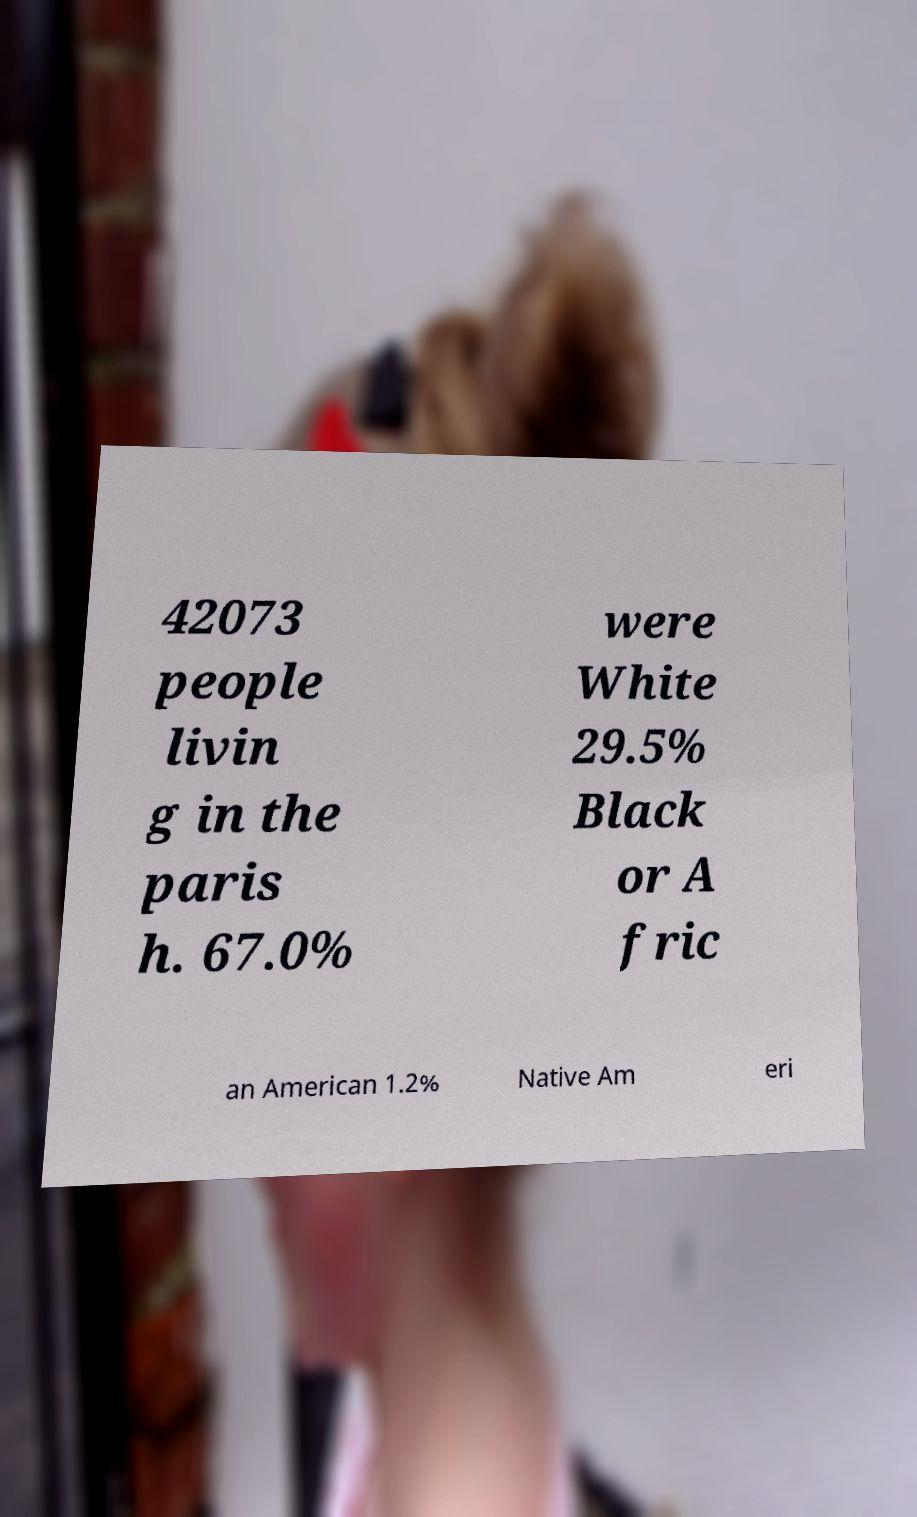I need the written content from this picture converted into text. Can you do that? 42073 people livin g in the paris h. 67.0% were White 29.5% Black or A fric an American 1.2% Native Am eri 